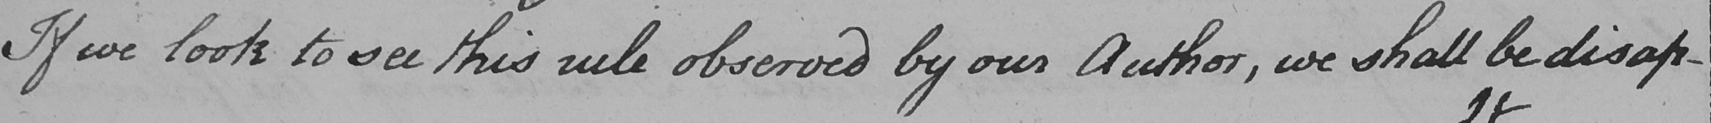What is written in this line of handwriting? If we look to see this rule observed by our Author , we shall be disap - 